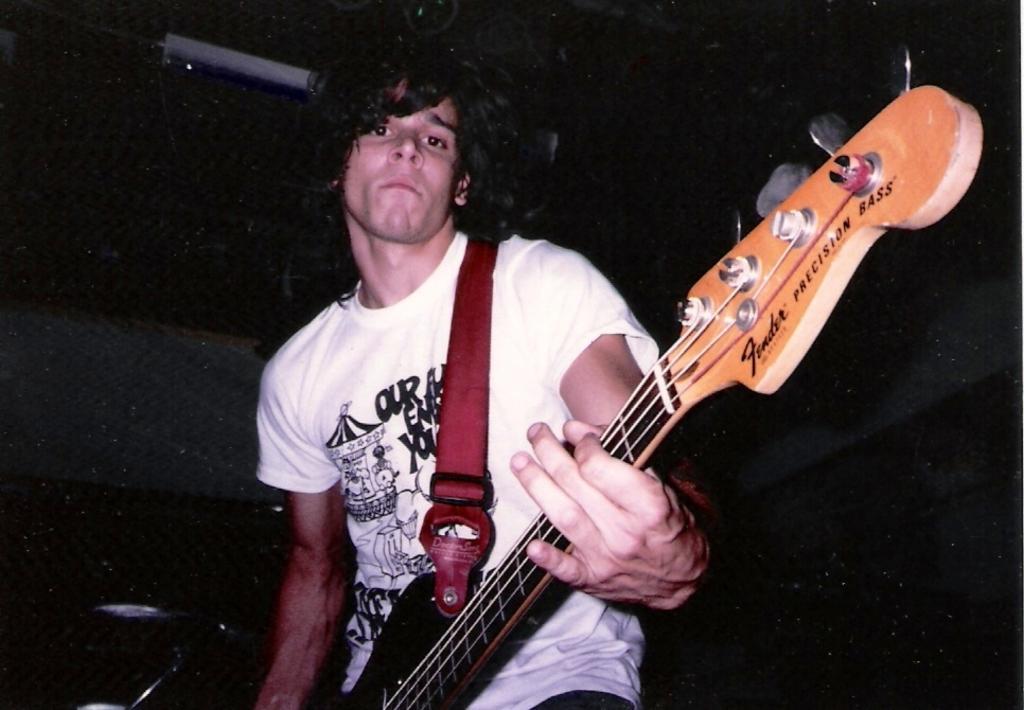In one or two sentences, can you explain what this image depicts? In this image there is a man holding a guitar and playing it. 